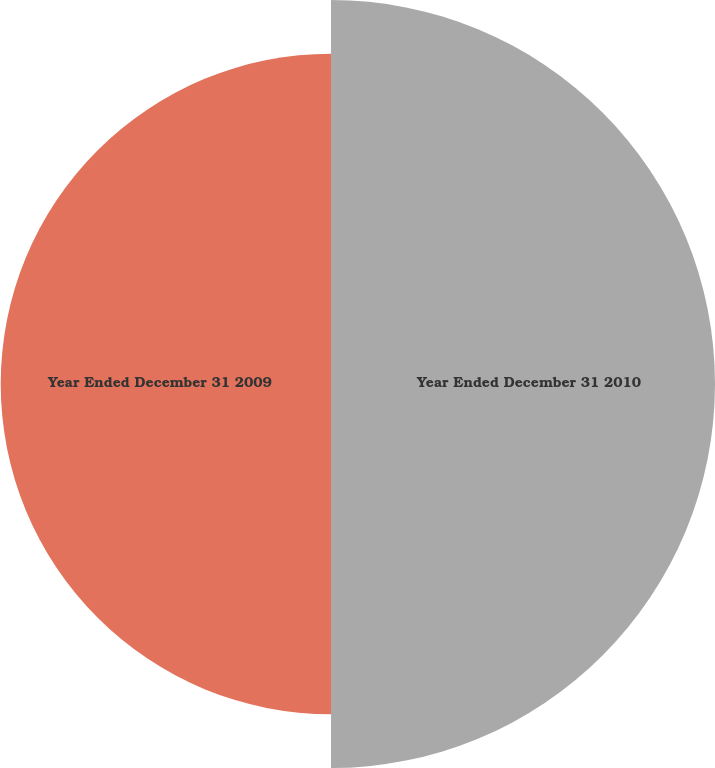Convert chart to OTSL. <chart><loc_0><loc_0><loc_500><loc_500><pie_chart><fcel>Year Ended December 31 2010<fcel>Year Ended December 31 2009<nl><fcel>53.76%<fcel>46.24%<nl></chart> 